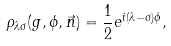<formula> <loc_0><loc_0><loc_500><loc_500>\rho _ { \lambda \sigma } ( g , \phi , \vec { n } ) = \frac { 1 } { 2 } e ^ { i ( \lambda - \sigma ) \phi } ,</formula> 